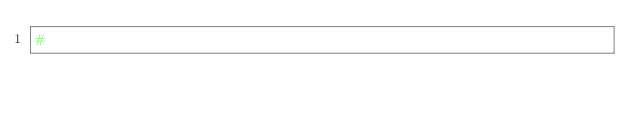Convert code to text. <code><loc_0><loc_0><loc_500><loc_500><_Python_>#</code> 